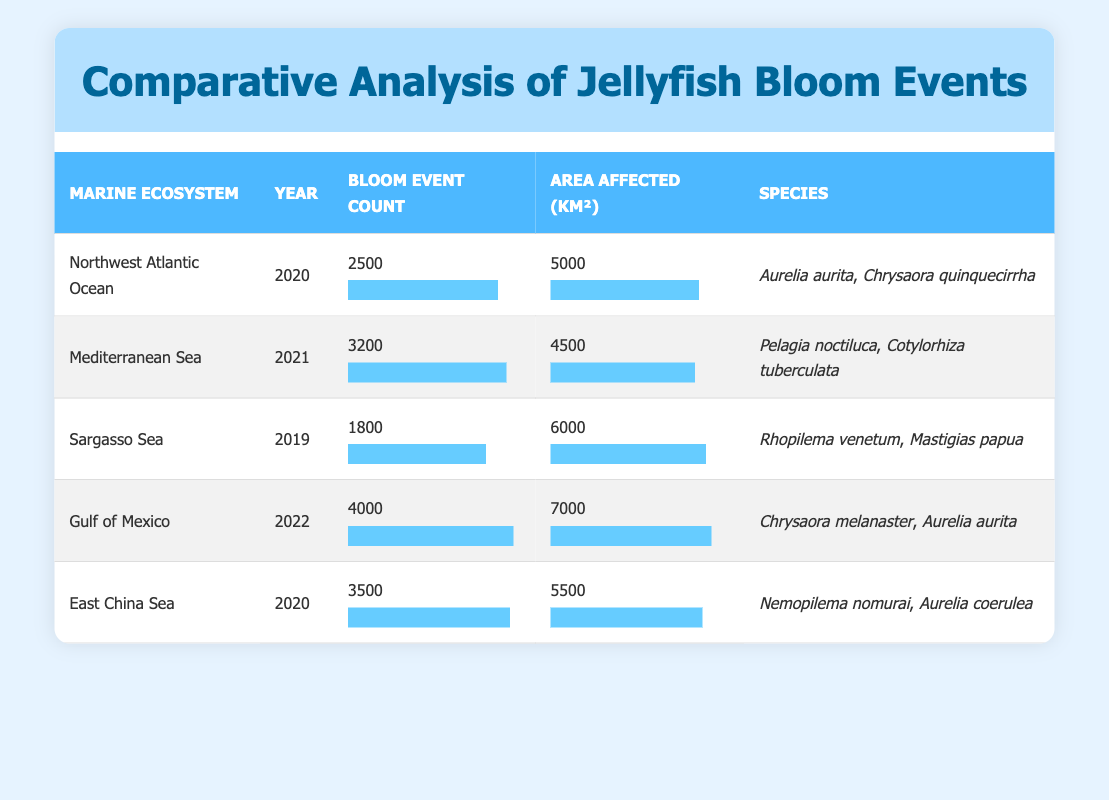What is the bloom event count for the Gulf of Mexico in 2022? The table indicates that the bloom event count for the Gulf of Mexico in 2022 is listed directly in the corresponding row.
Answer: 4000 Which marine ecosystem had the highest bloom event count? By comparing the bloom event counts listed in the table, the Gulf of Mexico in 2022 had the highest bloom event count with 4000 events.
Answer: Gulf of Mexico How many species were reported during the jellyfish bloom event in the East China Sea in 2020? From the East China Sea row, two species are listed: Nemopilema nomurai and Aurelia coerulea, indicating that there were two species reported.
Answer: 2 What is the average area affected by jellyfish blooms across all ecosystems in the years provided? To find the average area affected, we sum the areas affected (5000 + 4500 + 6000 + 7000 + 5500 = 30000) and then divide by the number of ecosystems (30000/5 = 6000).
Answer: 6000 Did the Sargasso Sea experience a higher bloom event count than the Northwest Atlantic Ocean in 2020? The Sargasso Sea had a bloom event count of 1800, whereas the Northwest Atlantic Ocean had 2500. Since 2500 is greater than 1800, the answer is no.
Answer: No Which year had the lowest recorded number of jellyfish bloom events? By reviewing the bloom counts year by year, the lowest count is found in 2019 with the Sargasso Sea showing 1800 events.
Answer: 2019 What is the difference in area affected by jellyfish blooms between the Mediterranean Sea and the Gulf of Mexico? The Mediterranean Sea had an area affected of 4500 km² and the Gulf of Mexico had 7000 km². The difference is calculated as 7000 - 4500 = 2500 km².
Answer: 2500 km² In which marine ecosystem did the species Chrysaora aurita bloom? The species Aurelia aurita (also known as Chrysaora aurita) was reported in both the Northwest Atlantic Ocean and the Gulf of Mexico.
Answer: Northwest Atlantic Ocean, Gulf of Mexico Has the average bloom event count increased from 2019 to 2021? The bloom event counts for 2019 (1800), 2020 (2500 and 3500), and 2021 (3200) are analyzed. The average for 2019 is 1800; for 2020 it is (2500+3500)/2 = 3000; and for 2021, it remains 3200. Since 3000 > 1800 and 3200 > 3000, the average event count has increased from 2019 to 2021.
Answer: Yes 